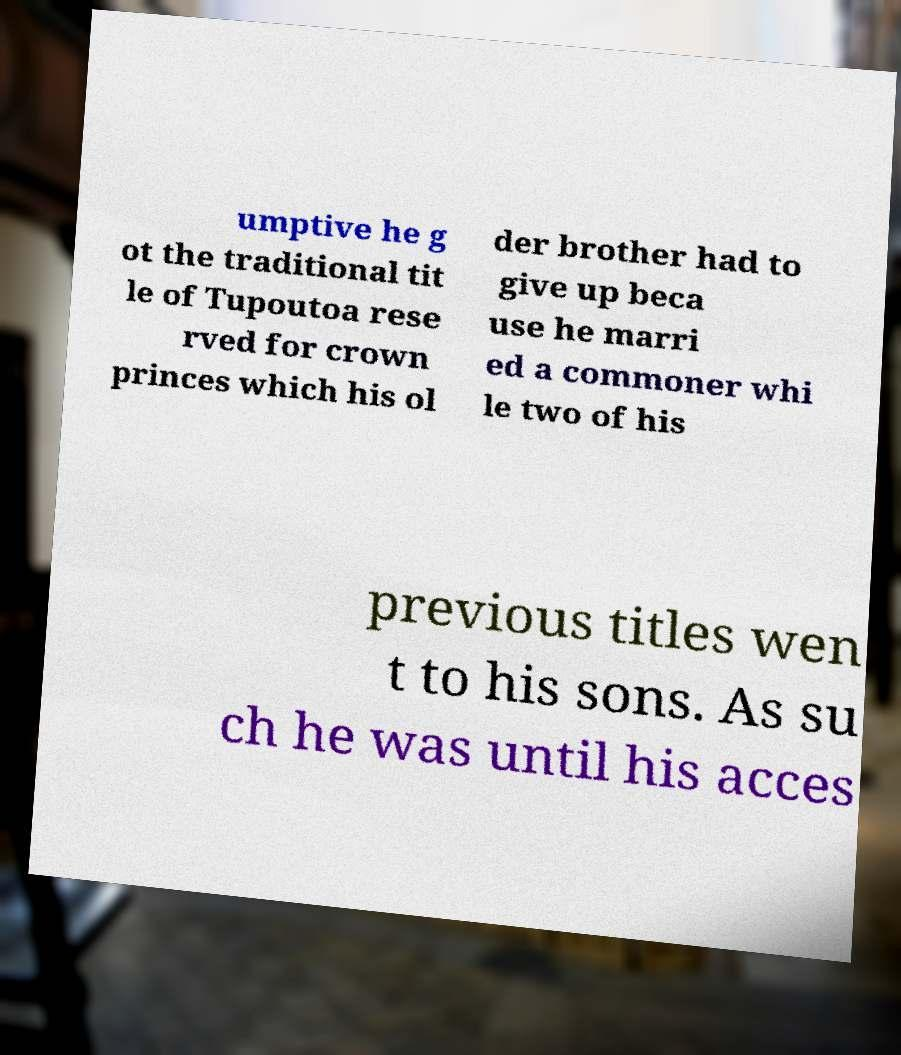Could you extract and type out the text from this image? umptive he g ot the traditional tit le of Tupoutoa rese rved for crown princes which his ol der brother had to give up beca use he marri ed a commoner whi le two of his previous titles wen t to his sons. As su ch he was until his acces 